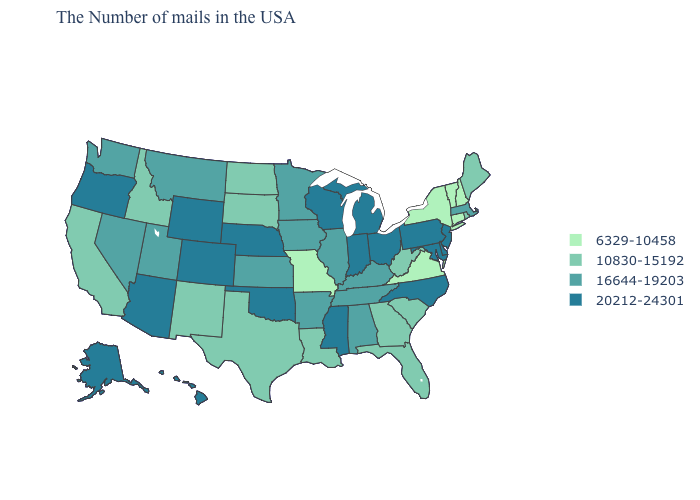Is the legend a continuous bar?
Write a very short answer. No. What is the highest value in states that border New York?
Write a very short answer. 20212-24301. Which states have the lowest value in the USA?
Keep it brief. New Hampshire, Vermont, Connecticut, New York, Virginia, Missouri. Which states have the lowest value in the South?
Short answer required. Virginia. Does Vermont have the highest value in the USA?
Be succinct. No. What is the value of Utah?
Answer briefly. 16644-19203. What is the value of Alaska?
Give a very brief answer. 20212-24301. Name the states that have a value in the range 16644-19203?
Keep it brief. Massachusetts, Kentucky, Alabama, Tennessee, Illinois, Arkansas, Minnesota, Iowa, Kansas, Utah, Montana, Nevada, Washington. What is the value of Virginia?
Give a very brief answer. 6329-10458. Which states have the highest value in the USA?
Be succinct. New Jersey, Delaware, Maryland, Pennsylvania, North Carolina, Ohio, Michigan, Indiana, Wisconsin, Mississippi, Nebraska, Oklahoma, Wyoming, Colorado, Arizona, Oregon, Alaska, Hawaii. What is the lowest value in the MidWest?
Short answer required. 6329-10458. Does Virginia have the lowest value in the USA?
Short answer required. Yes. Does the map have missing data?
Be succinct. No. Among the states that border Iowa , does Missouri have the lowest value?
Be succinct. Yes. Name the states that have a value in the range 10830-15192?
Write a very short answer. Maine, Rhode Island, South Carolina, West Virginia, Florida, Georgia, Louisiana, Texas, South Dakota, North Dakota, New Mexico, Idaho, California. 